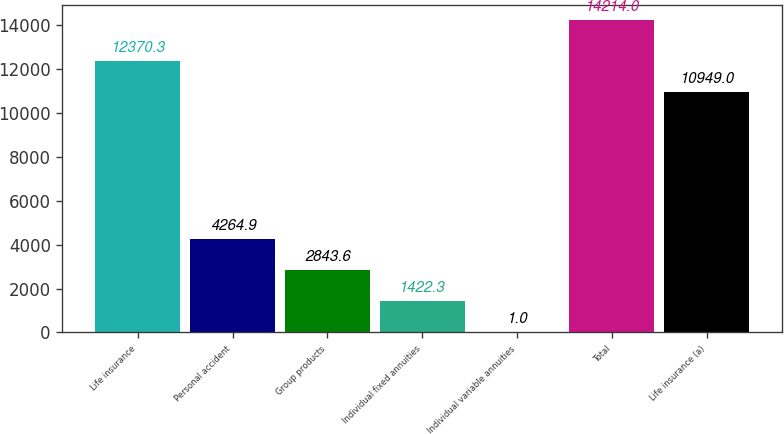Convert chart. <chart><loc_0><loc_0><loc_500><loc_500><bar_chart><fcel>Life insurance<fcel>Personal accident<fcel>Group products<fcel>Individual fixed annuities<fcel>Individual variable annuities<fcel>Total<fcel>Life insurance (a)<nl><fcel>12370.3<fcel>4264.9<fcel>2843.6<fcel>1422.3<fcel>1<fcel>14214<fcel>10949<nl></chart> 